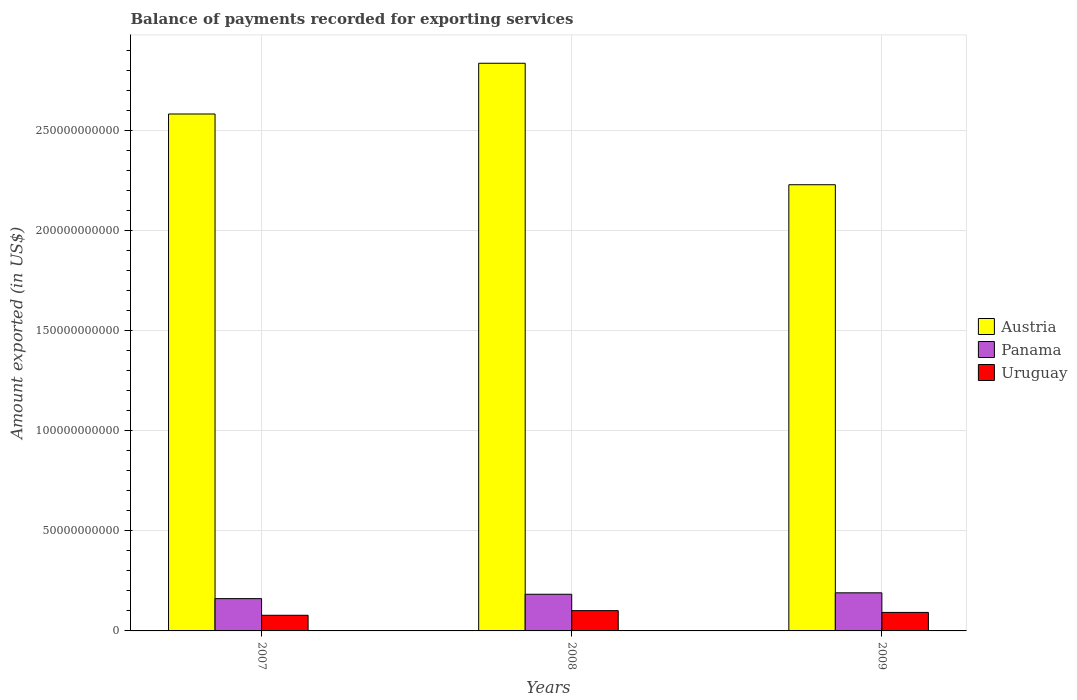How many different coloured bars are there?
Provide a short and direct response. 3. How many groups of bars are there?
Ensure brevity in your answer.  3. How many bars are there on the 1st tick from the left?
Provide a short and direct response. 3. What is the label of the 1st group of bars from the left?
Offer a very short reply. 2007. What is the amount exported in Austria in 2007?
Your answer should be very brief. 2.58e+11. Across all years, what is the maximum amount exported in Panama?
Your answer should be very brief. 1.90e+1. Across all years, what is the minimum amount exported in Panama?
Keep it short and to the point. 1.61e+1. In which year was the amount exported in Uruguay maximum?
Offer a terse response. 2008. In which year was the amount exported in Austria minimum?
Your answer should be compact. 2009. What is the total amount exported in Uruguay in the graph?
Provide a short and direct response. 2.72e+1. What is the difference between the amount exported in Uruguay in 2008 and that in 2009?
Offer a very short reply. 8.87e+08. What is the difference between the amount exported in Uruguay in 2007 and the amount exported in Panama in 2009?
Your answer should be very brief. -1.12e+1. What is the average amount exported in Uruguay per year?
Offer a terse response. 9.06e+09. In the year 2008, what is the difference between the amount exported in Panama and amount exported in Austria?
Offer a terse response. -2.65e+11. What is the ratio of the amount exported in Panama in 2008 to that in 2009?
Offer a very short reply. 0.96. Is the difference between the amount exported in Panama in 2007 and 2009 greater than the difference between the amount exported in Austria in 2007 and 2009?
Your answer should be very brief. No. What is the difference between the highest and the second highest amount exported in Austria?
Provide a succinct answer. 2.53e+1. What is the difference between the highest and the lowest amount exported in Panama?
Your answer should be very brief. 2.90e+09. What does the 3rd bar from the left in 2009 represents?
Offer a very short reply. Uruguay. Are all the bars in the graph horizontal?
Your answer should be compact. No. What is the difference between two consecutive major ticks on the Y-axis?
Your response must be concise. 5.00e+1. Does the graph contain grids?
Ensure brevity in your answer.  Yes. How are the legend labels stacked?
Provide a short and direct response. Vertical. What is the title of the graph?
Give a very brief answer. Balance of payments recorded for exporting services. Does "Colombia" appear as one of the legend labels in the graph?
Make the answer very short. No. What is the label or title of the Y-axis?
Your response must be concise. Amount exported (in US$). What is the Amount exported (in US$) in Austria in 2007?
Provide a succinct answer. 2.58e+11. What is the Amount exported (in US$) of Panama in 2007?
Your answer should be compact. 1.61e+1. What is the Amount exported (in US$) in Uruguay in 2007?
Your answer should be compact. 7.82e+09. What is the Amount exported (in US$) of Austria in 2008?
Your answer should be very brief. 2.83e+11. What is the Amount exported (in US$) in Panama in 2008?
Give a very brief answer. 1.83e+1. What is the Amount exported (in US$) of Uruguay in 2008?
Your answer should be very brief. 1.01e+1. What is the Amount exported (in US$) of Austria in 2009?
Keep it short and to the point. 2.23e+11. What is the Amount exported (in US$) in Panama in 2009?
Offer a very short reply. 1.90e+1. What is the Amount exported (in US$) of Uruguay in 2009?
Keep it short and to the point. 9.24e+09. Across all years, what is the maximum Amount exported (in US$) in Austria?
Give a very brief answer. 2.83e+11. Across all years, what is the maximum Amount exported (in US$) of Panama?
Make the answer very short. 1.90e+1. Across all years, what is the maximum Amount exported (in US$) of Uruguay?
Keep it short and to the point. 1.01e+1. Across all years, what is the minimum Amount exported (in US$) in Austria?
Make the answer very short. 2.23e+11. Across all years, what is the minimum Amount exported (in US$) of Panama?
Offer a terse response. 1.61e+1. Across all years, what is the minimum Amount exported (in US$) of Uruguay?
Your answer should be very brief. 7.82e+09. What is the total Amount exported (in US$) of Austria in the graph?
Offer a very short reply. 7.64e+11. What is the total Amount exported (in US$) in Panama in the graph?
Keep it short and to the point. 5.35e+1. What is the total Amount exported (in US$) of Uruguay in the graph?
Offer a terse response. 2.72e+1. What is the difference between the Amount exported (in US$) in Austria in 2007 and that in 2008?
Offer a very short reply. -2.53e+1. What is the difference between the Amount exported (in US$) of Panama in 2007 and that in 2008?
Ensure brevity in your answer.  -2.19e+09. What is the difference between the Amount exported (in US$) of Uruguay in 2007 and that in 2008?
Offer a very short reply. -2.31e+09. What is the difference between the Amount exported (in US$) of Austria in 2007 and that in 2009?
Ensure brevity in your answer.  3.53e+1. What is the difference between the Amount exported (in US$) of Panama in 2007 and that in 2009?
Ensure brevity in your answer.  -2.90e+09. What is the difference between the Amount exported (in US$) of Uruguay in 2007 and that in 2009?
Offer a very short reply. -1.42e+09. What is the difference between the Amount exported (in US$) in Austria in 2008 and that in 2009?
Offer a terse response. 6.07e+1. What is the difference between the Amount exported (in US$) in Panama in 2008 and that in 2009?
Your response must be concise. -7.11e+08. What is the difference between the Amount exported (in US$) in Uruguay in 2008 and that in 2009?
Provide a short and direct response. 8.87e+08. What is the difference between the Amount exported (in US$) in Austria in 2007 and the Amount exported (in US$) in Panama in 2008?
Provide a succinct answer. 2.40e+11. What is the difference between the Amount exported (in US$) of Austria in 2007 and the Amount exported (in US$) of Uruguay in 2008?
Make the answer very short. 2.48e+11. What is the difference between the Amount exported (in US$) of Panama in 2007 and the Amount exported (in US$) of Uruguay in 2008?
Give a very brief answer. 5.99e+09. What is the difference between the Amount exported (in US$) of Austria in 2007 and the Amount exported (in US$) of Panama in 2009?
Your answer should be very brief. 2.39e+11. What is the difference between the Amount exported (in US$) of Austria in 2007 and the Amount exported (in US$) of Uruguay in 2009?
Offer a very short reply. 2.49e+11. What is the difference between the Amount exported (in US$) in Panama in 2007 and the Amount exported (in US$) in Uruguay in 2009?
Offer a terse response. 6.88e+09. What is the difference between the Amount exported (in US$) of Austria in 2008 and the Amount exported (in US$) of Panama in 2009?
Provide a succinct answer. 2.64e+11. What is the difference between the Amount exported (in US$) in Austria in 2008 and the Amount exported (in US$) in Uruguay in 2009?
Your answer should be compact. 2.74e+11. What is the difference between the Amount exported (in US$) in Panama in 2008 and the Amount exported (in US$) in Uruguay in 2009?
Your response must be concise. 9.07e+09. What is the average Amount exported (in US$) in Austria per year?
Ensure brevity in your answer.  2.55e+11. What is the average Amount exported (in US$) in Panama per year?
Provide a short and direct response. 1.78e+1. What is the average Amount exported (in US$) in Uruguay per year?
Your response must be concise. 9.06e+09. In the year 2007, what is the difference between the Amount exported (in US$) in Austria and Amount exported (in US$) in Panama?
Offer a very short reply. 2.42e+11. In the year 2007, what is the difference between the Amount exported (in US$) of Austria and Amount exported (in US$) of Uruguay?
Keep it short and to the point. 2.50e+11. In the year 2007, what is the difference between the Amount exported (in US$) in Panama and Amount exported (in US$) in Uruguay?
Make the answer very short. 8.31e+09. In the year 2008, what is the difference between the Amount exported (in US$) of Austria and Amount exported (in US$) of Panama?
Offer a terse response. 2.65e+11. In the year 2008, what is the difference between the Amount exported (in US$) in Austria and Amount exported (in US$) in Uruguay?
Offer a very short reply. 2.73e+11. In the year 2008, what is the difference between the Amount exported (in US$) in Panama and Amount exported (in US$) in Uruguay?
Give a very brief answer. 8.18e+09. In the year 2009, what is the difference between the Amount exported (in US$) of Austria and Amount exported (in US$) of Panama?
Offer a terse response. 2.04e+11. In the year 2009, what is the difference between the Amount exported (in US$) in Austria and Amount exported (in US$) in Uruguay?
Make the answer very short. 2.14e+11. In the year 2009, what is the difference between the Amount exported (in US$) of Panama and Amount exported (in US$) of Uruguay?
Ensure brevity in your answer.  9.78e+09. What is the ratio of the Amount exported (in US$) of Austria in 2007 to that in 2008?
Provide a succinct answer. 0.91. What is the ratio of the Amount exported (in US$) in Panama in 2007 to that in 2008?
Provide a succinct answer. 0.88. What is the ratio of the Amount exported (in US$) of Uruguay in 2007 to that in 2008?
Keep it short and to the point. 0.77. What is the ratio of the Amount exported (in US$) in Austria in 2007 to that in 2009?
Offer a very short reply. 1.16. What is the ratio of the Amount exported (in US$) of Panama in 2007 to that in 2009?
Ensure brevity in your answer.  0.85. What is the ratio of the Amount exported (in US$) in Uruguay in 2007 to that in 2009?
Provide a short and direct response. 0.85. What is the ratio of the Amount exported (in US$) of Austria in 2008 to that in 2009?
Offer a terse response. 1.27. What is the ratio of the Amount exported (in US$) in Panama in 2008 to that in 2009?
Provide a short and direct response. 0.96. What is the ratio of the Amount exported (in US$) in Uruguay in 2008 to that in 2009?
Provide a succinct answer. 1.1. What is the difference between the highest and the second highest Amount exported (in US$) of Austria?
Give a very brief answer. 2.53e+1. What is the difference between the highest and the second highest Amount exported (in US$) in Panama?
Your response must be concise. 7.11e+08. What is the difference between the highest and the second highest Amount exported (in US$) of Uruguay?
Make the answer very short. 8.87e+08. What is the difference between the highest and the lowest Amount exported (in US$) in Austria?
Your response must be concise. 6.07e+1. What is the difference between the highest and the lowest Amount exported (in US$) of Panama?
Offer a terse response. 2.90e+09. What is the difference between the highest and the lowest Amount exported (in US$) in Uruguay?
Your answer should be compact. 2.31e+09. 